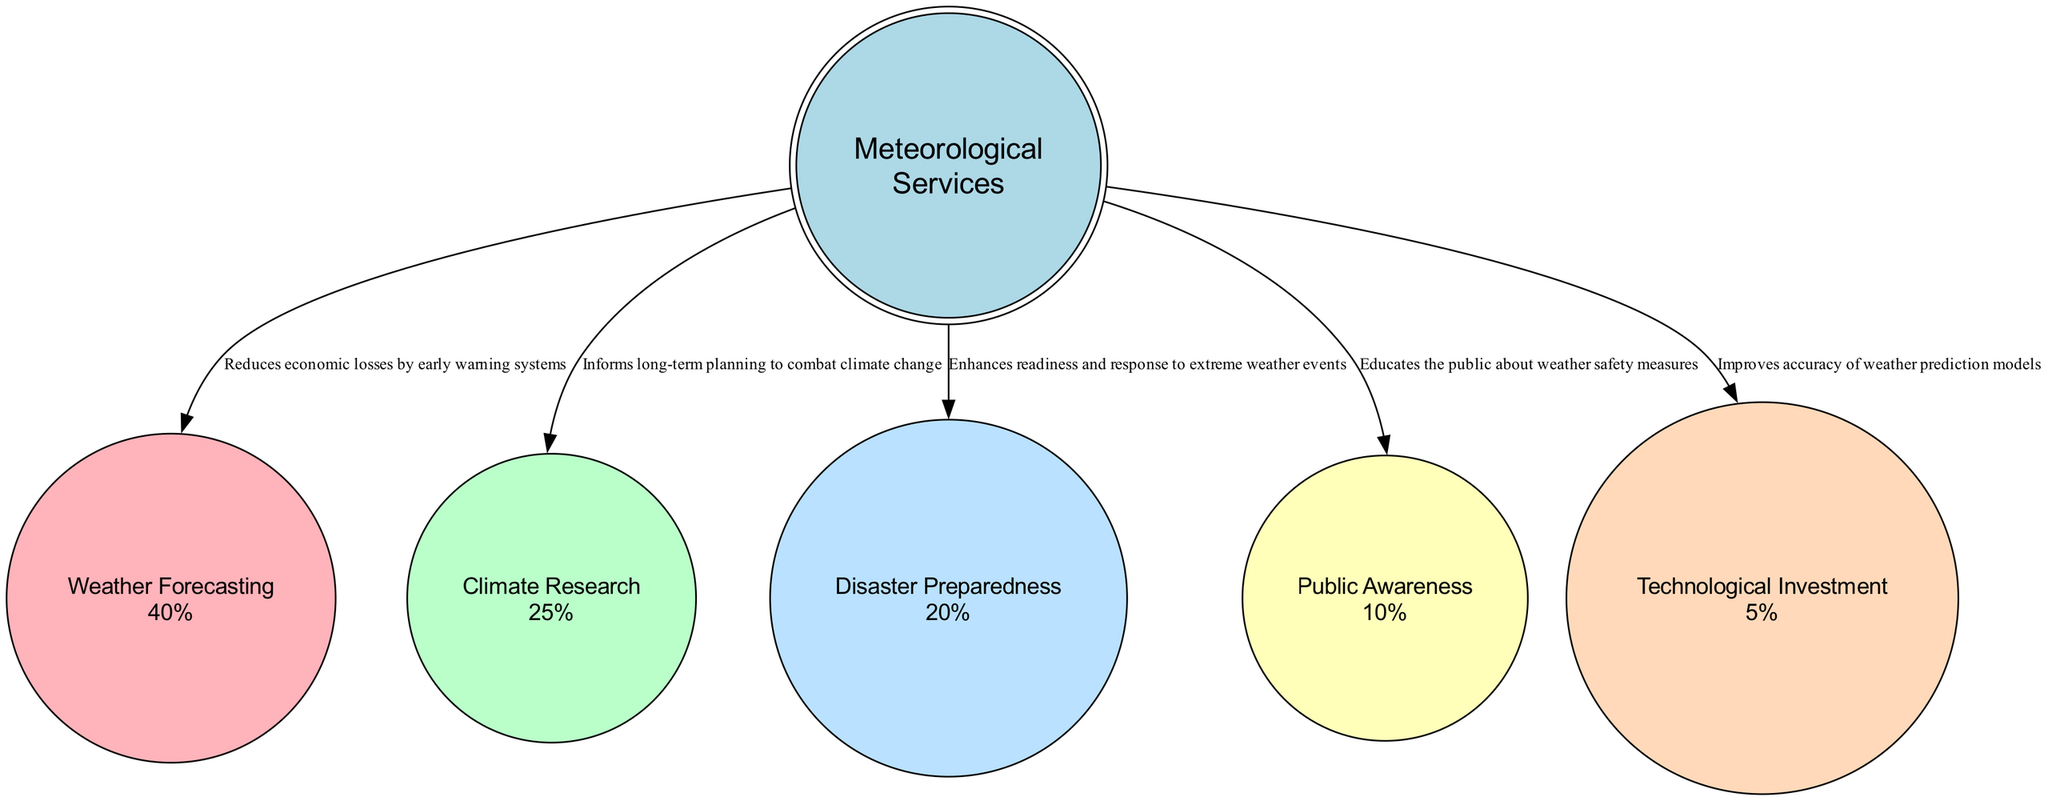What is the percentage allocated to Weather Forecasting? The pie chart indicates that Weather Forecasting has a designated percentage of 40%. This value is clearly stated in the node representing Weather Forecasting.
Answer: 40% How many nodes are depicted in the diagram? The diagram includes five nodes: Weather Forecasting, Climate Research, Disaster Preparedness, Public Awareness, and Technological Investment. Counting each of these nodes gives a total of five.
Answer: 5 Which service has the least budget allocation? Upon reviewing the pie chart, Technological Investment with a percentage of 5% is the service with the least budget allocation. This is confirmed by examining the percentages of all the nodes.
Answer: Technological Investment What is the impact of Climate Research on public safety? The impact of Climate Research is stated as informing long-term planning to combat climate change. This impact is shown as a description in the edge connecting the node to the center.
Answer: Informs long-term planning to combat climate change How do you calculate the total percentage of budget allocated to Disaster Preparedness and Public Awareness? Disaster Preparedness has a budget allocation of 20% and Public Awareness has a budget allocation of 10%. Adding these two values together gives a total of 30%.
Answer: 30% What impact does Weather Forecasting have on reducing economic losses? The diagram indicates that Weather Forecasting reduces economic losses by utilizing early warning systems as stated in the node’s description. This clearly outlines its benefit.
Answer: Reduces economic losses by early warning systems Which two services together account for 65% of the total budget allocation? Weather Forecasting (40%) and Climate Research (25%) are combined to reach a total of 65% when added together. This can be verified by summing the respective percentages from the diagram.
Answer: Weather Forecasting and Climate Research What is the main focus of the 10% budget spent on Public Awareness? The impact outlined for Public Awareness is to educate the public about weather safety measures. This is listed as the primary focus in the diagram’s edge connected to this node.
Answer: Educates the public about weather safety measures 